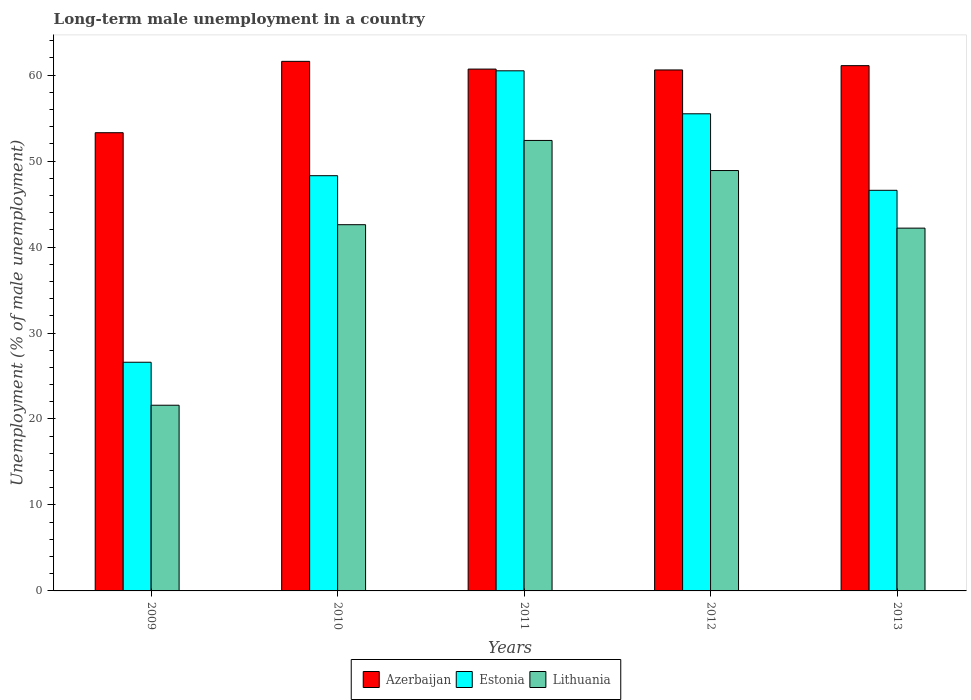How many different coloured bars are there?
Offer a very short reply. 3. How many groups of bars are there?
Your answer should be very brief. 5. Are the number of bars per tick equal to the number of legend labels?
Ensure brevity in your answer.  Yes. What is the percentage of long-term unemployed male population in Azerbaijan in 2011?
Your answer should be very brief. 60.7. Across all years, what is the maximum percentage of long-term unemployed male population in Lithuania?
Ensure brevity in your answer.  52.4. Across all years, what is the minimum percentage of long-term unemployed male population in Azerbaijan?
Give a very brief answer. 53.3. In which year was the percentage of long-term unemployed male population in Azerbaijan maximum?
Your response must be concise. 2010. In which year was the percentage of long-term unemployed male population in Lithuania minimum?
Your answer should be compact. 2009. What is the total percentage of long-term unemployed male population in Azerbaijan in the graph?
Your response must be concise. 297.3. What is the difference between the percentage of long-term unemployed male population in Azerbaijan in 2011 and that in 2013?
Offer a very short reply. -0.4. What is the difference between the percentage of long-term unemployed male population in Lithuania in 2011 and the percentage of long-term unemployed male population in Azerbaijan in 2012?
Ensure brevity in your answer.  -8.2. What is the average percentage of long-term unemployed male population in Estonia per year?
Your answer should be very brief. 47.5. In the year 2011, what is the difference between the percentage of long-term unemployed male population in Estonia and percentage of long-term unemployed male population in Lithuania?
Your answer should be compact. 8.1. What is the ratio of the percentage of long-term unemployed male population in Estonia in 2010 to that in 2013?
Your answer should be very brief. 1.04. What is the difference between the highest and the second highest percentage of long-term unemployed male population in Azerbaijan?
Offer a very short reply. 0.5. What is the difference between the highest and the lowest percentage of long-term unemployed male population in Estonia?
Your answer should be compact. 33.9. What does the 3rd bar from the left in 2009 represents?
Provide a short and direct response. Lithuania. What does the 2nd bar from the right in 2013 represents?
Your response must be concise. Estonia. Is it the case that in every year, the sum of the percentage of long-term unemployed male population in Lithuania and percentage of long-term unemployed male population in Estonia is greater than the percentage of long-term unemployed male population in Azerbaijan?
Give a very brief answer. No. How many bars are there?
Ensure brevity in your answer.  15. How many years are there in the graph?
Provide a succinct answer. 5. Does the graph contain any zero values?
Offer a very short reply. No. What is the title of the graph?
Your answer should be very brief. Long-term male unemployment in a country. Does "West Bank and Gaza" appear as one of the legend labels in the graph?
Your response must be concise. No. What is the label or title of the Y-axis?
Give a very brief answer. Unemployment (% of male unemployment). What is the Unemployment (% of male unemployment) of Azerbaijan in 2009?
Provide a succinct answer. 53.3. What is the Unemployment (% of male unemployment) of Estonia in 2009?
Keep it short and to the point. 26.6. What is the Unemployment (% of male unemployment) in Lithuania in 2009?
Give a very brief answer. 21.6. What is the Unemployment (% of male unemployment) in Azerbaijan in 2010?
Offer a terse response. 61.6. What is the Unemployment (% of male unemployment) of Estonia in 2010?
Your response must be concise. 48.3. What is the Unemployment (% of male unemployment) in Lithuania in 2010?
Your response must be concise. 42.6. What is the Unemployment (% of male unemployment) of Azerbaijan in 2011?
Keep it short and to the point. 60.7. What is the Unemployment (% of male unemployment) of Estonia in 2011?
Your answer should be very brief. 60.5. What is the Unemployment (% of male unemployment) of Lithuania in 2011?
Your response must be concise. 52.4. What is the Unemployment (% of male unemployment) of Azerbaijan in 2012?
Offer a very short reply. 60.6. What is the Unemployment (% of male unemployment) of Estonia in 2012?
Ensure brevity in your answer.  55.5. What is the Unemployment (% of male unemployment) in Lithuania in 2012?
Keep it short and to the point. 48.9. What is the Unemployment (% of male unemployment) of Azerbaijan in 2013?
Your answer should be compact. 61.1. What is the Unemployment (% of male unemployment) in Estonia in 2013?
Provide a short and direct response. 46.6. What is the Unemployment (% of male unemployment) of Lithuania in 2013?
Your response must be concise. 42.2. Across all years, what is the maximum Unemployment (% of male unemployment) of Azerbaijan?
Ensure brevity in your answer.  61.6. Across all years, what is the maximum Unemployment (% of male unemployment) in Estonia?
Offer a very short reply. 60.5. Across all years, what is the maximum Unemployment (% of male unemployment) in Lithuania?
Provide a succinct answer. 52.4. Across all years, what is the minimum Unemployment (% of male unemployment) in Azerbaijan?
Make the answer very short. 53.3. Across all years, what is the minimum Unemployment (% of male unemployment) of Estonia?
Ensure brevity in your answer.  26.6. Across all years, what is the minimum Unemployment (% of male unemployment) in Lithuania?
Your response must be concise. 21.6. What is the total Unemployment (% of male unemployment) of Azerbaijan in the graph?
Your response must be concise. 297.3. What is the total Unemployment (% of male unemployment) of Estonia in the graph?
Your answer should be very brief. 237.5. What is the total Unemployment (% of male unemployment) in Lithuania in the graph?
Provide a succinct answer. 207.7. What is the difference between the Unemployment (% of male unemployment) of Azerbaijan in 2009 and that in 2010?
Provide a succinct answer. -8.3. What is the difference between the Unemployment (% of male unemployment) in Estonia in 2009 and that in 2010?
Keep it short and to the point. -21.7. What is the difference between the Unemployment (% of male unemployment) in Azerbaijan in 2009 and that in 2011?
Keep it short and to the point. -7.4. What is the difference between the Unemployment (% of male unemployment) of Estonia in 2009 and that in 2011?
Offer a terse response. -33.9. What is the difference between the Unemployment (% of male unemployment) in Lithuania in 2009 and that in 2011?
Offer a terse response. -30.8. What is the difference between the Unemployment (% of male unemployment) in Azerbaijan in 2009 and that in 2012?
Give a very brief answer. -7.3. What is the difference between the Unemployment (% of male unemployment) in Estonia in 2009 and that in 2012?
Your response must be concise. -28.9. What is the difference between the Unemployment (% of male unemployment) in Lithuania in 2009 and that in 2012?
Give a very brief answer. -27.3. What is the difference between the Unemployment (% of male unemployment) in Azerbaijan in 2009 and that in 2013?
Provide a succinct answer. -7.8. What is the difference between the Unemployment (% of male unemployment) of Estonia in 2009 and that in 2013?
Your answer should be compact. -20. What is the difference between the Unemployment (% of male unemployment) of Lithuania in 2009 and that in 2013?
Your answer should be very brief. -20.6. What is the difference between the Unemployment (% of male unemployment) in Azerbaijan in 2010 and that in 2011?
Your answer should be very brief. 0.9. What is the difference between the Unemployment (% of male unemployment) in Estonia in 2010 and that in 2011?
Your answer should be compact. -12.2. What is the difference between the Unemployment (% of male unemployment) of Azerbaijan in 2010 and that in 2012?
Your answer should be very brief. 1. What is the difference between the Unemployment (% of male unemployment) in Estonia in 2010 and that in 2013?
Your answer should be compact. 1.7. What is the difference between the Unemployment (% of male unemployment) in Lithuania in 2010 and that in 2013?
Your response must be concise. 0.4. What is the difference between the Unemployment (% of male unemployment) in Estonia in 2011 and that in 2013?
Keep it short and to the point. 13.9. What is the difference between the Unemployment (% of male unemployment) of Estonia in 2012 and that in 2013?
Offer a very short reply. 8.9. What is the difference between the Unemployment (% of male unemployment) of Azerbaijan in 2009 and the Unemployment (% of male unemployment) of Estonia in 2010?
Your answer should be compact. 5. What is the difference between the Unemployment (% of male unemployment) of Azerbaijan in 2009 and the Unemployment (% of male unemployment) of Estonia in 2011?
Provide a succinct answer. -7.2. What is the difference between the Unemployment (% of male unemployment) of Azerbaijan in 2009 and the Unemployment (% of male unemployment) of Lithuania in 2011?
Your answer should be compact. 0.9. What is the difference between the Unemployment (% of male unemployment) of Estonia in 2009 and the Unemployment (% of male unemployment) of Lithuania in 2011?
Keep it short and to the point. -25.8. What is the difference between the Unemployment (% of male unemployment) of Azerbaijan in 2009 and the Unemployment (% of male unemployment) of Estonia in 2012?
Your answer should be compact. -2.2. What is the difference between the Unemployment (% of male unemployment) in Azerbaijan in 2009 and the Unemployment (% of male unemployment) in Lithuania in 2012?
Make the answer very short. 4.4. What is the difference between the Unemployment (% of male unemployment) in Estonia in 2009 and the Unemployment (% of male unemployment) in Lithuania in 2012?
Give a very brief answer. -22.3. What is the difference between the Unemployment (% of male unemployment) of Azerbaijan in 2009 and the Unemployment (% of male unemployment) of Lithuania in 2013?
Offer a terse response. 11.1. What is the difference between the Unemployment (% of male unemployment) in Estonia in 2009 and the Unemployment (% of male unemployment) in Lithuania in 2013?
Give a very brief answer. -15.6. What is the difference between the Unemployment (% of male unemployment) of Azerbaijan in 2010 and the Unemployment (% of male unemployment) of Estonia in 2011?
Your answer should be very brief. 1.1. What is the difference between the Unemployment (% of male unemployment) in Azerbaijan in 2010 and the Unemployment (% of male unemployment) in Lithuania in 2011?
Make the answer very short. 9.2. What is the difference between the Unemployment (% of male unemployment) in Estonia in 2010 and the Unemployment (% of male unemployment) in Lithuania in 2011?
Offer a very short reply. -4.1. What is the difference between the Unemployment (% of male unemployment) of Estonia in 2010 and the Unemployment (% of male unemployment) of Lithuania in 2012?
Your answer should be very brief. -0.6. What is the difference between the Unemployment (% of male unemployment) of Azerbaijan in 2010 and the Unemployment (% of male unemployment) of Lithuania in 2013?
Offer a terse response. 19.4. What is the difference between the Unemployment (% of male unemployment) in Estonia in 2010 and the Unemployment (% of male unemployment) in Lithuania in 2013?
Offer a terse response. 6.1. What is the difference between the Unemployment (% of male unemployment) of Azerbaijan in 2011 and the Unemployment (% of male unemployment) of Estonia in 2013?
Your answer should be very brief. 14.1. What is the difference between the Unemployment (% of male unemployment) in Azerbaijan in 2012 and the Unemployment (% of male unemployment) in Estonia in 2013?
Offer a terse response. 14. What is the difference between the Unemployment (% of male unemployment) of Estonia in 2012 and the Unemployment (% of male unemployment) of Lithuania in 2013?
Make the answer very short. 13.3. What is the average Unemployment (% of male unemployment) in Azerbaijan per year?
Give a very brief answer. 59.46. What is the average Unemployment (% of male unemployment) of Estonia per year?
Offer a very short reply. 47.5. What is the average Unemployment (% of male unemployment) in Lithuania per year?
Provide a succinct answer. 41.54. In the year 2009, what is the difference between the Unemployment (% of male unemployment) in Azerbaijan and Unemployment (% of male unemployment) in Estonia?
Keep it short and to the point. 26.7. In the year 2009, what is the difference between the Unemployment (% of male unemployment) in Azerbaijan and Unemployment (% of male unemployment) in Lithuania?
Offer a terse response. 31.7. In the year 2009, what is the difference between the Unemployment (% of male unemployment) of Estonia and Unemployment (% of male unemployment) of Lithuania?
Your answer should be very brief. 5. In the year 2010, what is the difference between the Unemployment (% of male unemployment) in Azerbaijan and Unemployment (% of male unemployment) in Estonia?
Give a very brief answer. 13.3. In the year 2010, what is the difference between the Unemployment (% of male unemployment) in Azerbaijan and Unemployment (% of male unemployment) in Lithuania?
Ensure brevity in your answer.  19. In the year 2011, what is the difference between the Unemployment (% of male unemployment) of Azerbaijan and Unemployment (% of male unemployment) of Estonia?
Make the answer very short. 0.2. In the year 2012, what is the difference between the Unemployment (% of male unemployment) of Azerbaijan and Unemployment (% of male unemployment) of Estonia?
Offer a terse response. 5.1. In the year 2012, what is the difference between the Unemployment (% of male unemployment) of Azerbaijan and Unemployment (% of male unemployment) of Lithuania?
Give a very brief answer. 11.7. In the year 2013, what is the difference between the Unemployment (% of male unemployment) of Estonia and Unemployment (% of male unemployment) of Lithuania?
Provide a succinct answer. 4.4. What is the ratio of the Unemployment (% of male unemployment) in Azerbaijan in 2009 to that in 2010?
Offer a very short reply. 0.87. What is the ratio of the Unemployment (% of male unemployment) of Estonia in 2009 to that in 2010?
Offer a very short reply. 0.55. What is the ratio of the Unemployment (% of male unemployment) of Lithuania in 2009 to that in 2010?
Ensure brevity in your answer.  0.51. What is the ratio of the Unemployment (% of male unemployment) of Azerbaijan in 2009 to that in 2011?
Your response must be concise. 0.88. What is the ratio of the Unemployment (% of male unemployment) in Estonia in 2009 to that in 2011?
Offer a very short reply. 0.44. What is the ratio of the Unemployment (% of male unemployment) of Lithuania in 2009 to that in 2011?
Keep it short and to the point. 0.41. What is the ratio of the Unemployment (% of male unemployment) of Azerbaijan in 2009 to that in 2012?
Give a very brief answer. 0.88. What is the ratio of the Unemployment (% of male unemployment) of Estonia in 2009 to that in 2012?
Provide a short and direct response. 0.48. What is the ratio of the Unemployment (% of male unemployment) in Lithuania in 2009 to that in 2012?
Your answer should be very brief. 0.44. What is the ratio of the Unemployment (% of male unemployment) of Azerbaijan in 2009 to that in 2013?
Your answer should be very brief. 0.87. What is the ratio of the Unemployment (% of male unemployment) of Estonia in 2009 to that in 2013?
Ensure brevity in your answer.  0.57. What is the ratio of the Unemployment (% of male unemployment) in Lithuania in 2009 to that in 2013?
Make the answer very short. 0.51. What is the ratio of the Unemployment (% of male unemployment) in Azerbaijan in 2010 to that in 2011?
Offer a very short reply. 1.01. What is the ratio of the Unemployment (% of male unemployment) in Estonia in 2010 to that in 2011?
Your answer should be very brief. 0.8. What is the ratio of the Unemployment (% of male unemployment) of Lithuania in 2010 to that in 2011?
Provide a short and direct response. 0.81. What is the ratio of the Unemployment (% of male unemployment) of Azerbaijan in 2010 to that in 2012?
Offer a very short reply. 1.02. What is the ratio of the Unemployment (% of male unemployment) of Estonia in 2010 to that in 2012?
Ensure brevity in your answer.  0.87. What is the ratio of the Unemployment (% of male unemployment) in Lithuania in 2010 to that in 2012?
Offer a terse response. 0.87. What is the ratio of the Unemployment (% of male unemployment) of Azerbaijan in 2010 to that in 2013?
Make the answer very short. 1.01. What is the ratio of the Unemployment (% of male unemployment) in Estonia in 2010 to that in 2013?
Give a very brief answer. 1.04. What is the ratio of the Unemployment (% of male unemployment) in Lithuania in 2010 to that in 2013?
Your answer should be very brief. 1.01. What is the ratio of the Unemployment (% of male unemployment) in Estonia in 2011 to that in 2012?
Your response must be concise. 1.09. What is the ratio of the Unemployment (% of male unemployment) in Lithuania in 2011 to that in 2012?
Offer a very short reply. 1.07. What is the ratio of the Unemployment (% of male unemployment) of Estonia in 2011 to that in 2013?
Offer a very short reply. 1.3. What is the ratio of the Unemployment (% of male unemployment) of Lithuania in 2011 to that in 2013?
Provide a short and direct response. 1.24. What is the ratio of the Unemployment (% of male unemployment) of Estonia in 2012 to that in 2013?
Give a very brief answer. 1.19. What is the ratio of the Unemployment (% of male unemployment) of Lithuania in 2012 to that in 2013?
Provide a succinct answer. 1.16. What is the difference between the highest and the second highest Unemployment (% of male unemployment) in Estonia?
Give a very brief answer. 5. What is the difference between the highest and the second highest Unemployment (% of male unemployment) in Lithuania?
Make the answer very short. 3.5. What is the difference between the highest and the lowest Unemployment (% of male unemployment) of Azerbaijan?
Keep it short and to the point. 8.3. What is the difference between the highest and the lowest Unemployment (% of male unemployment) of Estonia?
Keep it short and to the point. 33.9. What is the difference between the highest and the lowest Unemployment (% of male unemployment) in Lithuania?
Your answer should be compact. 30.8. 